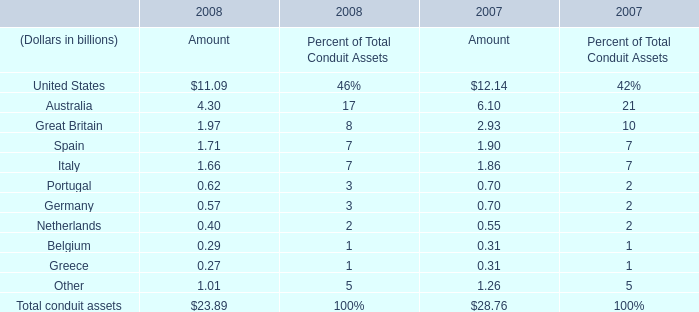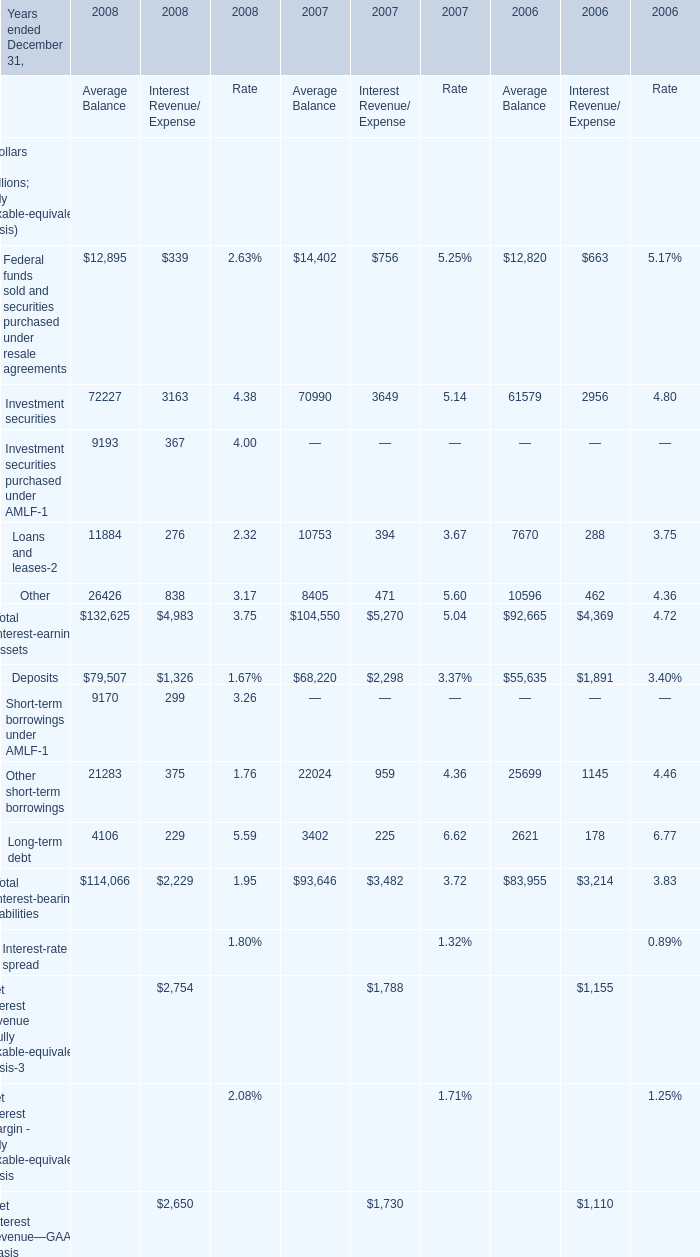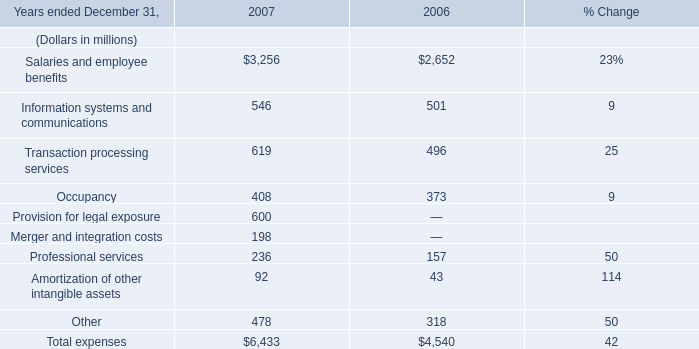What is the Amount of the Total conduit assets in 2007? (in billion) 
Answer: 28.76. 